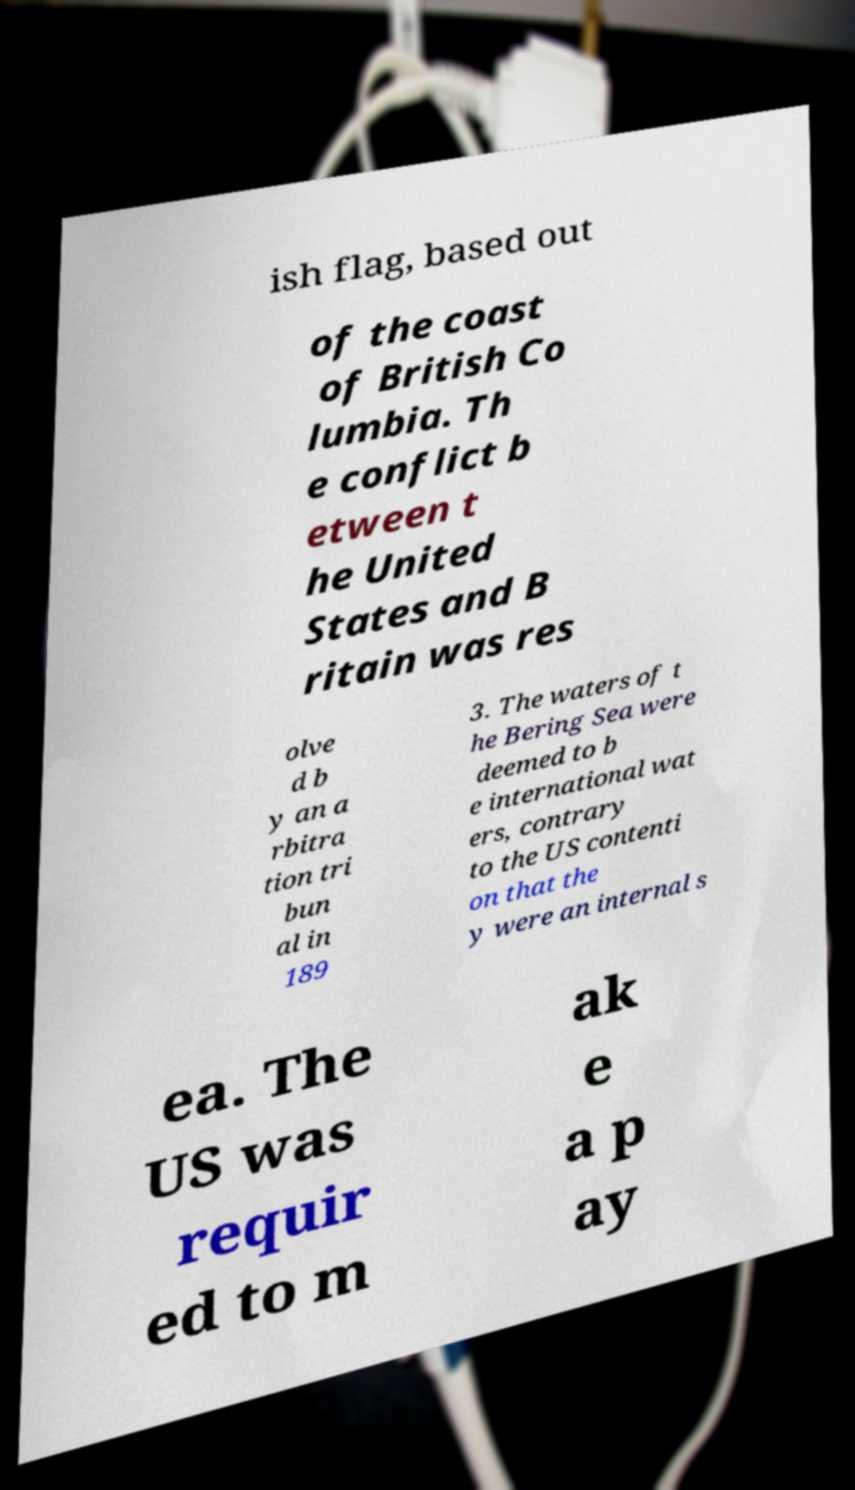Could you extract and type out the text from this image? ish flag, based out of the coast of British Co lumbia. Th e conflict b etween t he United States and B ritain was res olve d b y an a rbitra tion tri bun al in 189 3. The waters of t he Bering Sea were deemed to b e international wat ers, contrary to the US contenti on that the y were an internal s ea. The US was requir ed to m ak e a p ay 